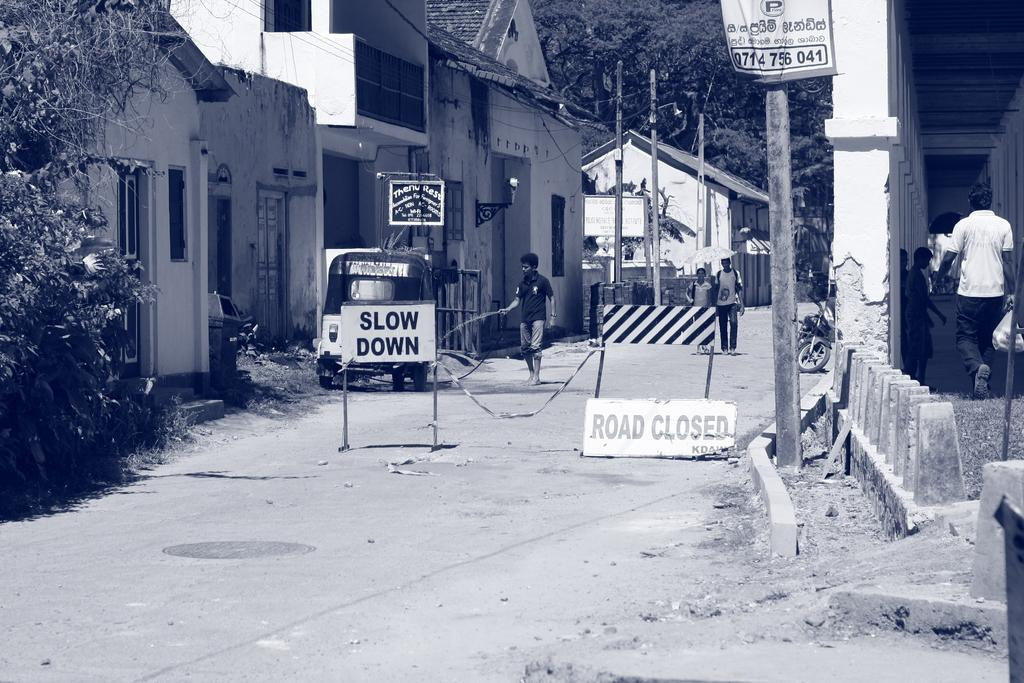What can be seen in the middle of the image? There are poles in the middle of the image. What is attached to the poles? There are sign boards on the poles. What is happening behind the poles? There are people standing and walking behind the poles. What type of natural elements can be seen in the image? There are trees visible in the image. What type of man-made structures are present in the image? There are buildings in the image. What type of transportation is visible in the image? There are vehicles in the image. What team is responsible for the loss of the ice in the image? There is no ice or team present in the image, so it is not possible to determine any loss or responsibility. 